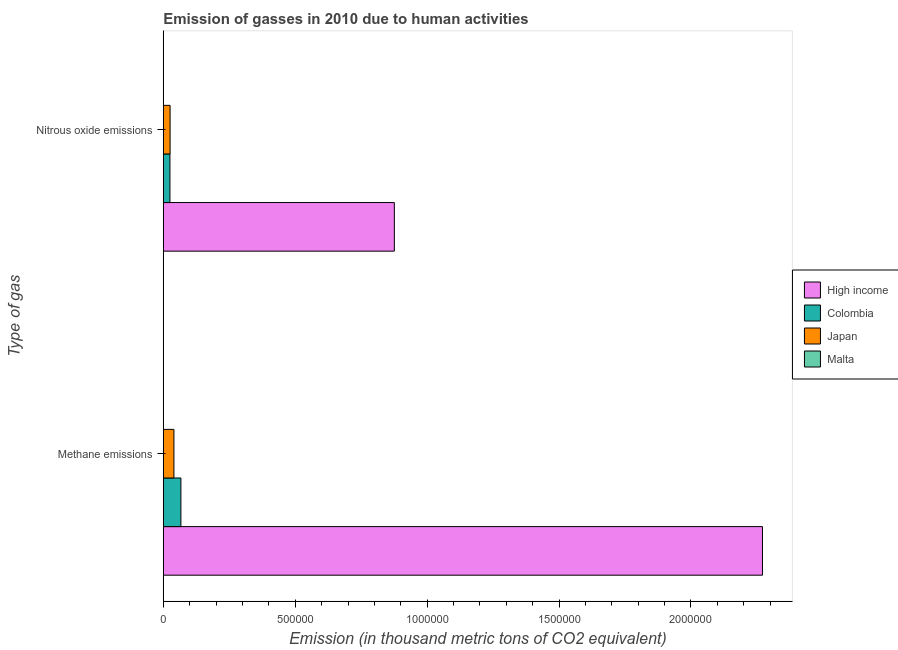How many groups of bars are there?
Make the answer very short. 2. Are the number of bars on each tick of the Y-axis equal?
Offer a terse response. Yes. How many bars are there on the 2nd tick from the top?
Your response must be concise. 4. What is the label of the 2nd group of bars from the top?
Your answer should be compact. Methane emissions. What is the amount of methane emissions in Colombia?
Make the answer very short. 6.67e+04. Across all countries, what is the maximum amount of nitrous oxide emissions?
Ensure brevity in your answer.  8.76e+05. Across all countries, what is the minimum amount of methane emissions?
Provide a succinct answer. 235.4. In which country was the amount of methane emissions maximum?
Provide a succinct answer. High income. In which country was the amount of methane emissions minimum?
Offer a terse response. Malta. What is the total amount of methane emissions in the graph?
Your answer should be compact. 2.38e+06. What is the difference between the amount of methane emissions in High income and that in Japan?
Your answer should be compact. 2.23e+06. What is the difference between the amount of methane emissions in Japan and the amount of nitrous oxide emissions in High income?
Give a very brief answer. -8.35e+05. What is the average amount of methane emissions per country?
Your answer should be compact. 5.95e+05. What is the difference between the amount of methane emissions and amount of nitrous oxide emissions in High income?
Keep it short and to the point. 1.40e+06. What is the ratio of the amount of methane emissions in High income to that in Japan?
Your answer should be compact. 56.4. Is the amount of nitrous oxide emissions in High income less than that in Japan?
Provide a short and direct response. No. In how many countries, is the amount of nitrous oxide emissions greater than the average amount of nitrous oxide emissions taken over all countries?
Give a very brief answer. 1. What does the 4th bar from the bottom in Nitrous oxide emissions represents?
Your response must be concise. Malta. Are all the bars in the graph horizontal?
Keep it short and to the point. Yes. How many countries are there in the graph?
Offer a terse response. 4. Does the graph contain grids?
Your response must be concise. No. What is the title of the graph?
Make the answer very short. Emission of gasses in 2010 due to human activities. Does "Benin" appear as one of the legend labels in the graph?
Your answer should be compact. No. What is the label or title of the X-axis?
Your answer should be very brief. Emission (in thousand metric tons of CO2 equivalent). What is the label or title of the Y-axis?
Provide a succinct answer. Type of gas. What is the Emission (in thousand metric tons of CO2 equivalent) in High income in Methane emissions?
Ensure brevity in your answer.  2.27e+06. What is the Emission (in thousand metric tons of CO2 equivalent) of Colombia in Methane emissions?
Make the answer very short. 6.67e+04. What is the Emission (in thousand metric tons of CO2 equivalent) in Japan in Methane emissions?
Your response must be concise. 4.03e+04. What is the Emission (in thousand metric tons of CO2 equivalent) in Malta in Methane emissions?
Ensure brevity in your answer.  235.4. What is the Emission (in thousand metric tons of CO2 equivalent) of High income in Nitrous oxide emissions?
Keep it short and to the point. 8.76e+05. What is the Emission (in thousand metric tons of CO2 equivalent) of Colombia in Nitrous oxide emissions?
Provide a short and direct response. 2.51e+04. What is the Emission (in thousand metric tons of CO2 equivalent) of Japan in Nitrous oxide emissions?
Your answer should be compact. 2.57e+04. What is the Emission (in thousand metric tons of CO2 equivalent) of Malta in Nitrous oxide emissions?
Make the answer very short. 60.9. Across all Type of gas, what is the maximum Emission (in thousand metric tons of CO2 equivalent) in High income?
Provide a short and direct response. 2.27e+06. Across all Type of gas, what is the maximum Emission (in thousand metric tons of CO2 equivalent) of Colombia?
Your answer should be very brief. 6.67e+04. Across all Type of gas, what is the maximum Emission (in thousand metric tons of CO2 equivalent) of Japan?
Your response must be concise. 4.03e+04. Across all Type of gas, what is the maximum Emission (in thousand metric tons of CO2 equivalent) in Malta?
Offer a terse response. 235.4. Across all Type of gas, what is the minimum Emission (in thousand metric tons of CO2 equivalent) of High income?
Make the answer very short. 8.76e+05. Across all Type of gas, what is the minimum Emission (in thousand metric tons of CO2 equivalent) in Colombia?
Offer a very short reply. 2.51e+04. Across all Type of gas, what is the minimum Emission (in thousand metric tons of CO2 equivalent) of Japan?
Provide a short and direct response. 2.57e+04. Across all Type of gas, what is the minimum Emission (in thousand metric tons of CO2 equivalent) in Malta?
Provide a succinct answer. 60.9. What is the total Emission (in thousand metric tons of CO2 equivalent) in High income in the graph?
Make the answer very short. 3.15e+06. What is the total Emission (in thousand metric tons of CO2 equivalent) of Colombia in the graph?
Make the answer very short. 9.18e+04. What is the total Emission (in thousand metric tons of CO2 equivalent) of Japan in the graph?
Offer a terse response. 6.60e+04. What is the total Emission (in thousand metric tons of CO2 equivalent) of Malta in the graph?
Your response must be concise. 296.3. What is the difference between the Emission (in thousand metric tons of CO2 equivalent) of High income in Methane emissions and that in Nitrous oxide emissions?
Provide a short and direct response. 1.40e+06. What is the difference between the Emission (in thousand metric tons of CO2 equivalent) of Colombia in Methane emissions and that in Nitrous oxide emissions?
Offer a very short reply. 4.16e+04. What is the difference between the Emission (in thousand metric tons of CO2 equivalent) in Japan in Methane emissions and that in Nitrous oxide emissions?
Give a very brief answer. 1.45e+04. What is the difference between the Emission (in thousand metric tons of CO2 equivalent) of Malta in Methane emissions and that in Nitrous oxide emissions?
Your answer should be compact. 174.5. What is the difference between the Emission (in thousand metric tons of CO2 equivalent) in High income in Methane emissions and the Emission (in thousand metric tons of CO2 equivalent) in Colombia in Nitrous oxide emissions?
Give a very brief answer. 2.25e+06. What is the difference between the Emission (in thousand metric tons of CO2 equivalent) of High income in Methane emissions and the Emission (in thousand metric tons of CO2 equivalent) of Japan in Nitrous oxide emissions?
Ensure brevity in your answer.  2.25e+06. What is the difference between the Emission (in thousand metric tons of CO2 equivalent) of High income in Methane emissions and the Emission (in thousand metric tons of CO2 equivalent) of Malta in Nitrous oxide emissions?
Provide a short and direct response. 2.27e+06. What is the difference between the Emission (in thousand metric tons of CO2 equivalent) of Colombia in Methane emissions and the Emission (in thousand metric tons of CO2 equivalent) of Japan in Nitrous oxide emissions?
Provide a short and direct response. 4.10e+04. What is the difference between the Emission (in thousand metric tons of CO2 equivalent) of Colombia in Methane emissions and the Emission (in thousand metric tons of CO2 equivalent) of Malta in Nitrous oxide emissions?
Your response must be concise. 6.66e+04. What is the difference between the Emission (in thousand metric tons of CO2 equivalent) in Japan in Methane emissions and the Emission (in thousand metric tons of CO2 equivalent) in Malta in Nitrous oxide emissions?
Provide a succinct answer. 4.02e+04. What is the average Emission (in thousand metric tons of CO2 equivalent) in High income per Type of gas?
Your answer should be compact. 1.57e+06. What is the average Emission (in thousand metric tons of CO2 equivalent) of Colombia per Type of gas?
Ensure brevity in your answer.  4.59e+04. What is the average Emission (in thousand metric tons of CO2 equivalent) of Japan per Type of gas?
Your response must be concise. 3.30e+04. What is the average Emission (in thousand metric tons of CO2 equivalent) in Malta per Type of gas?
Offer a terse response. 148.15. What is the difference between the Emission (in thousand metric tons of CO2 equivalent) in High income and Emission (in thousand metric tons of CO2 equivalent) in Colombia in Methane emissions?
Ensure brevity in your answer.  2.20e+06. What is the difference between the Emission (in thousand metric tons of CO2 equivalent) in High income and Emission (in thousand metric tons of CO2 equivalent) in Japan in Methane emissions?
Ensure brevity in your answer.  2.23e+06. What is the difference between the Emission (in thousand metric tons of CO2 equivalent) in High income and Emission (in thousand metric tons of CO2 equivalent) in Malta in Methane emissions?
Provide a short and direct response. 2.27e+06. What is the difference between the Emission (in thousand metric tons of CO2 equivalent) of Colombia and Emission (in thousand metric tons of CO2 equivalent) of Japan in Methane emissions?
Ensure brevity in your answer.  2.64e+04. What is the difference between the Emission (in thousand metric tons of CO2 equivalent) in Colombia and Emission (in thousand metric tons of CO2 equivalent) in Malta in Methane emissions?
Provide a short and direct response. 6.65e+04. What is the difference between the Emission (in thousand metric tons of CO2 equivalent) of Japan and Emission (in thousand metric tons of CO2 equivalent) of Malta in Methane emissions?
Keep it short and to the point. 4.00e+04. What is the difference between the Emission (in thousand metric tons of CO2 equivalent) of High income and Emission (in thousand metric tons of CO2 equivalent) of Colombia in Nitrous oxide emissions?
Your response must be concise. 8.51e+05. What is the difference between the Emission (in thousand metric tons of CO2 equivalent) of High income and Emission (in thousand metric tons of CO2 equivalent) of Japan in Nitrous oxide emissions?
Offer a very short reply. 8.50e+05. What is the difference between the Emission (in thousand metric tons of CO2 equivalent) of High income and Emission (in thousand metric tons of CO2 equivalent) of Malta in Nitrous oxide emissions?
Offer a terse response. 8.76e+05. What is the difference between the Emission (in thousand metric tons of CO2 equivalent) in Colombia and Emission (in thousand metric tons of CO2 equivalent) in Japan in Nitrous oxide emissions?
Offer a very short reply. -597.6. What is the difference between the Emission (in thousand metric tons of CO2 equivalent) of Colombia and Emission (in thousand metric tons of CO2 equivalent) of Malta in Nitrous oxide emissions?
Offer a terse response. 2.51e+04. What is the difference between the Emission (in thousand metric tons of CO2 equivalent) of Japan and Emission (in thousand metric tons of CO2 equivalent) of Malta in Nitrous oxide emissions?
Your answer should be very brief. 2.57e+04. What is the ratio of the Emission (in thousand metric tons of CO2 equivalent) in High income in Methane emissions to that in Nitrous oxide emissions?
Offer a very short reply. 2.59. What is the ratio of the Emission (in thousand metric tons of CO2 equivalent) of Colombia in Methane emissions to that in Nitrous oxide emissions?
Provide a short and direct response. 2.65. What is the ratio of the Emission (in thousand metric tons of CO2 equivalent) of Japan in Methane emissions to that in Nitrous oxide emissions?
Your answer should be very brief. 1.56. What is the ratio of the Emission (in thousand metric tons of CO2 equivalent) of Malta in Methane emissions to that in Nitrous oxide emissions?
Give a very brief answer. 3.87. What is the difference between the highest and the second highest Emission (in thousand metric tons of CO2 equivalent) of High income?
Ensure brevity in your answer.  1.40e+06. What is the difference between the highest and the second highest Emission (in thousand metric tons of CO2 equivalent) in Colombia?
Ensure brevity in your answer.  4.16e+04. What is the difference between the highest and the second highest Emission (in thousand metric tons of CO2 equivalent) of Japan?
Keep it short and to the point. 1.45e+04. What is the difference between the highest and the second highest Emission (in thousand metric tons of CO2 equivalent) in Malta?
Provide a short and direct response. 174.5. What is the difference between the highest and the lowest Emission (in thousand metric tons of CO2 equivalent) of High income?
Offer a very short reply. 1.40e+06. What is the difference between the highest and the lowest Emission (in thousand metric tons of CO2 equivalent) in Colombia?
Give a very brief answer. 4.16e+04. What is the difference between the highest and the lowest Emission (in thousand metric tons of CO2 equivalent) in Japan?
Give a very brief answer. 1.45e+04. What is the difference between the highest and the lowest Emission (in thousand metric tons of CO2 equivalent) of Malta?
Provide a short and direct response. 174.5. 